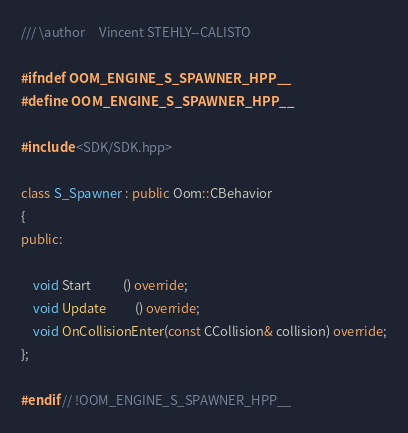<code> <loc_0><loc_0><loc_500><loc_500><_C++_>/// \author     Vincent STEHLY--CALISTO

#ifndef OOM_ENGINE_S_SPAWNER_HPP__
#define OOM_ENGINE_S_SPAWNER_HPP__

#include <SDK/SDK.hpp>

class S_Spawner : public Oom::CBehavior
{
public:

	void Start           () override;
	void Update          () override;
	void OnCollisionEnter(const CCollision& collision) override;
};

#endif // !OOM_ENGINE_S_SPAWNER_HPP__</code> 